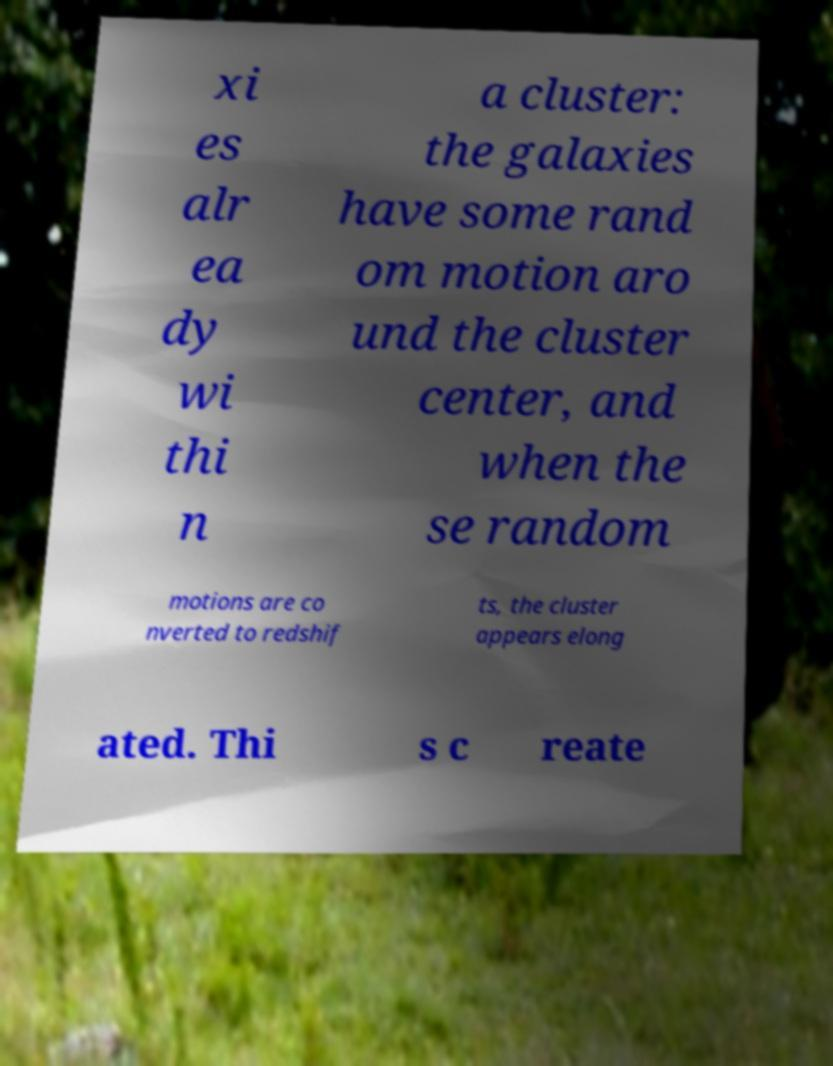Please read and relay the text visible in this image. What does it say? xi es alr ea dy wi thi n a cluster: the galaxies have some rand om motion aro und the cluster center, and when the se random motions are co nverted to redshif ts, the cluster appears elong ated. Thi s c reate 